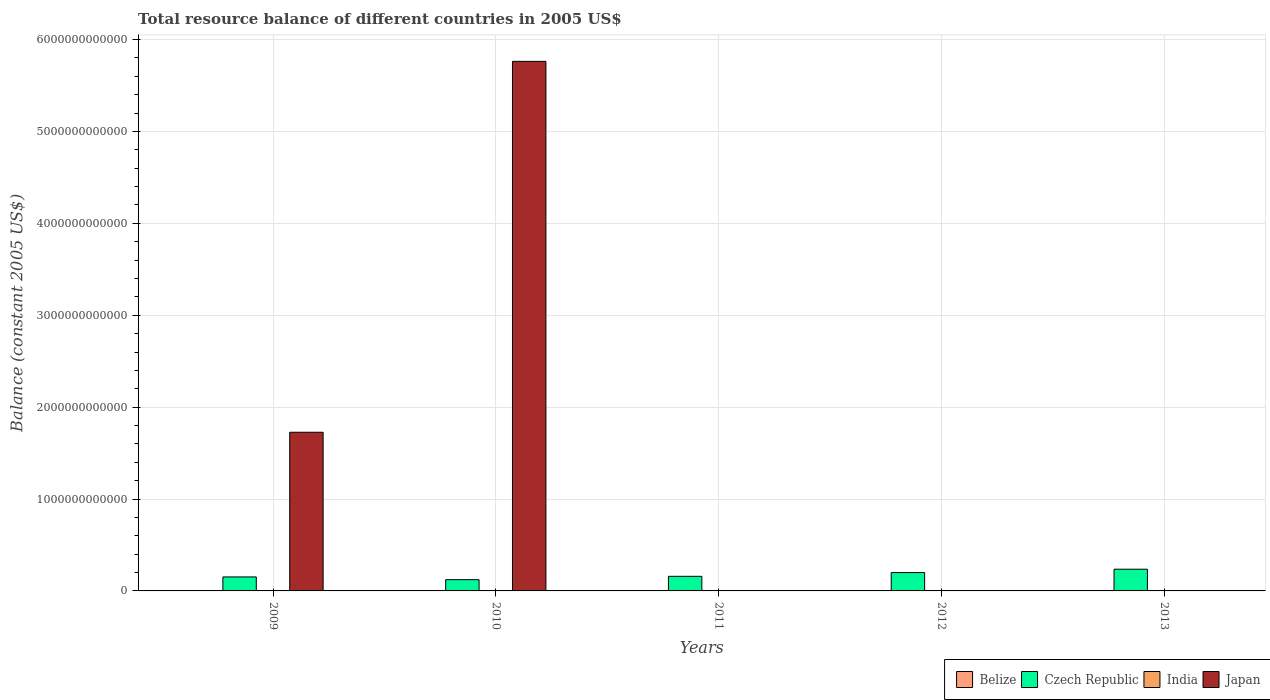Are the number of bars per tick equal to the number of legend labels?
Make the answer very short. No. What is the label of the 3rd group of bars from the left?
Your response must be concise. 2011. Across all years, what is the maximum total resource balance in Belize?
Offer a very short reply. 2.07e+07. Across all years, what is the minimum total resource balance in Belize?
Your answer should be compact. 0. What is the total total resource balance in Japan in the graph?
Your answer should be compact. 7.49e+12. What is the difference between the total resource balance in Czech Republic in 2011 and that in 2012?
Provide a short and direct response. -4.09e+1. What is the difference between the total resource balance in Belize in 2012 and the total resource balance in India in 2013?
Offer a very short reply. 0. What is the average total resource balance in India per year?
Your answer should be very brief. 0. In how many years, is the total resource balance in Japan greater than 4800000000000 US$?
Ensure brevity in your answer.  1. What is the difference between the highest and the lowest total resource balance in Czech Republic?
Your answer should be compact. 1.14e+11. In how many years, is the total resource balance in India greater than the average total resource balance in India taken over all years?
Provide a succinct answer. 0. Is the sum of the total resource balance in Czech Republic in 2009 and 2010 greater than the maximum total resource balance in India across all years?
Make the answer very short. Yes. How many years are there in the graph?
Your answer should be very brief. 5. What is the difference between two consecutive major ticks on the Y-axis?
Provide a succinct answer. 1.00e+12. Are the values on the major ticks of Y-axis written in scientific E-notation?
Offer a terse response. No. Does the graph contain any zero values?
Offer a terse response. Yes. Does the graph contain grids?
Provide a succinct answer. Yes. Where does the legend appear in the graph?
Offer a very short reply. Bottom right. How many legend labels are there?
Keep it short and to the point. 4. How are the legend labels stacked?
Ensure brevity in your answer.  Horizontal. What is the title of the graph?
Offer a terse response. Total resource balance of different countries in 2005 US$. What is the label or title of the Y-axis?
Offer a terse response. Balance (constant 2005 US$). What is the Balance (constant 2005 US$) in Belize in 2009?
Your response must be concise. 0. What is the Balance (constant 2005 US$) of Czech Republic in 2009?
Make the answer very short. 1.52e+11. What is the Balance (constant 2005 US$) in Japan in 2009?
Provide a short and direct response. 1.73e+12. What is the Balance (constant 2005 US$) of Belize in 2010?
Give a very brief answer. 2.07e+07. What is the Balance (constant 2005 US$) in Czech Republic in 2010?
Your answer should be compact. 1.23e+11. What is the Balance (constant 2005 US$) in Japan in 2010?
Offer a very short reply. 5.76e+12. What is the Balance (constant 2005 US$) of Belize in 2011?
Make the answer very short. 0. What is the Balance (constant 2005 US$) in Czech Republic in 2011?
Make the answer very short. 1.59e+11. What is the Balance (constant 2005 US$) of Czech Republic in 2012?
Your answer should be compact. 2.00e+11. What is the Balance (constant 2005 US$) of India in 2012?
Your answer should be compact. 0. What is the Balance (constant 2005 US$) in Japan in 2012?
Offer a very short reply. 0. What is the Balance (constant 2005 US$) in Czech Republic in 2013?
Provide a short and direct response. 2.36e+11. What is the Balance (constant 2005 US$) in India in 2013?
Your response must be concise. 0. What is the Balance (constant 2005 US$) of Japan in 2013?
Provide a succinct answer. 0. Across all years, what is the maximum Balance (constant 2005 US$) in Belize?
Ensure brevity in your answer.  2.07e+07. Across all years, what is the maximum Balance (constant 2005 US$) in Czech Republic?
Provide a short and direct response. 2.36e+11. Across all years, what is the maximum Balance (constant 2005 US$) of Japan?
Give a very brief answer. 5.76e+12. Across all years, what is the minimum Balance (constant 2005 US$) in Belize?
Ensure brevity in your answer.  0. Across all years, what is the minimum Balance (constant 2005 US$) of Czech Republic?
Keep it short and to the point. 1.23e+11. Across all years, what is the minimum Balance (constant 2005 US$) of Japan?
Your answer should be very brief. 0. What is the total Balance (constant 2005 US$) of Belize in the graph?
Offer a very short reply. 2.07e+07. What is the total Balance (constant 2005 US$) of Czech Republic in the graph?
Offer a very short reply. 8.70e+11. What is the total Balance (constant 2005 US$) of Japan in the graph?
Your answer should be very brief. 7.49e+12. What is the difference between the Balance (constant 2005 US$) in Czech Republic in 2009 and that in 2010?
Your response must be concise. 2.98e+1. What is the difference between the Balance (constant 2005 US$) of Japan in 2009 and that in 2010?
Keep it short and to the point. -4.04e+12. What is the difference between the Balance (constant 2005 US$) of Czech Republic in 2009 and that in 2011?
Your answer should be very brief. -6.51e+09. What is the difference between the Balance (constant 2005 US$) in Czech Republic in 2009 and that in 2012?
Your answer should be compact. -4.75e+1. What is the difference between the Balance (constant 2005 US$) of Czech Republic in 2009 and that in 2013?
Provide a short and direct response. -8.39e+1. What is the difference between the Balance (constant 2005 US$) of Czech Republic in 2010 and that in 2011?
Your response must be concise. -3.63e+1. What is the difference between the Balance (constant 2005 US$) of Czech Republic in 2010 and that in 2012?
Provide a short and direct response. -7.73e+1. What is the difference between the Balance (constant 2005 US$) of Czech Republic in 2010 and that in 2013?
Give a very brief answer. -1.14e+11. What is the difference between the Balance (constant 2005 US$) of Czech Republic in 2011 and that in 2012?
Your answer should be compact. -4.09e+1. What is the difference between the Balance (constant 2005 US$) of Czech Republic in 2011 and that in 2013?
Give a very brief answer. -7.74e+1. What is the difference between the Balance (constant 2005 US$) in Czech Republic in 2012 and that in 2013?
Your answer should be very brief. -3.64e+1. What is the difference between the Balance (constant 2005 US$) of Czech Republic in 2009 and the Balance (constant 2005 US$) of Japan in 2010?
Give a very brief answer. -5.61e+12. What is the difference between the Balance (constant 2005 US$) of Belize in 2010 and the Balance (constant 2005 US$) of Czech Republic in 2011?
Offer a very short reply. -1.59e+11. What is the difference between the Balance (constant 2005 US$) of Belize in 2010 and the Balance (constant 2005 US$) of Czech Republic in 2012?
Offer a terse response. -2.00e+11. What is the difference between the Balance (constant 2005 US$) of Belize in 2010 and the Balance (constant 2005 US$) of Czech Republic in 2013?
Your response must be concise. -2.36e+11. What is the average Balance (constant 2005 US$) in Belize per year?
Your answer should be compact. 4.14e+06. What is the average Balance (constant 2005 US$) in Czech Republic per year?
Your response must be concise. 1.74e+11. What is the average Balance (constant 2005 US$) of India per year?
Your answer should be compact. 0. What is the average Balance (constant 2005 US$) of Japan per year?
Provide a short and direct response. 1.50e+12. In the year 2009, what is the difference between the Balance (constant 2005 US$) in Czech Republic and Balance (constant 2005 US$) in Japan?
Provide a succinct answer. -1.57e+12. In the year 2010, what is the difference between the Balance (constant 2005 US$) of Belize and Balance (constant 2005 US$) of Czech Republic?
Offer a terse response. -1.22e+11. In the year 2010, what is the difference between the Balance (constant 2005 US$) of Belize and Balance (constant 2005 US$) of Japan?
Give a very brief answer. -5.76e+12. In the year 2010, what is the difference between the Balance (constant 2005 US$) of Czech Republic and Balance (constant 2005 US$) of Japan?
Your answer should be very brief. -5.64e+12. What is the ratio of the Balance (constant 2005 US$) of Czech Republic in 2009 to that in 2010?
Your answer should be compact. 1.24. What is the ratio of the Balance (constant 2005 US$) in Japan in 2009 to that in 2010?
Ensure brevity in your answer.  0.3. What is the ratio of the Balance (constant 2005 US$) of Czech Republic in 2009 to that in 2011?
Ensure brevity in your answer.  0.96. What is the ratio of the Balance (constant 2005 US$) in Czech Republic in 2009 to that in 2012?
Ensure brevity in your answer.  0.76. What is the ratio of the Balance (constant 2005 US$) of Czech Republic in 2009 to that in 2013?
Give a very brief answer. 0.64. What is the ratio of the Balance (constant 2005 US$) of Czech Republic in 2010 to that in 2011?
Your response must be concise. 0.77. What is the ratio of the Balance (constant 2005 US$) of Czech Republic in 2010 to that in 2012?
Your response must be concise. 0.61. What is the ratio of the Balance (constant 2005 US$) of Czech Republic in 2010 to that in 2013?
Give a very brief answer. 0.52. What is the ratio of the Balance (constant 2005 US$) of Czech Republic in 2011 to that in 2012?
Your answer should be compact. 0.8. What is the ratio of the Balance (constant 2005 US$) in Czech Republic in 2011 to that in 2013?
Keep it short and to the point. 0.67. What is the ratio of the Balance (constant 2005 US$) of Czech Republic in 2012 to that in 2013?
Your answer should be compact. 0.85. What is the difference between the highest and the second highest Balance (constant 2005 US$) in Czech Republic?
Your response must be concise. 3.64e+1. What is the difference between the highest and the lowest Balance (constant 2005 US$) in Belize?
Your answer should be very brief. 2.07e+07. What is the difference between the highest and the lowest Balance (constant 2005 US$) of Czech Republic?
Your answer should be very brief. 1.14e+11. What is the difference between the highest and the lowest Balance (constant 2005 US$) in Japan?
Provide a short and direct response. 5.76e+12. 